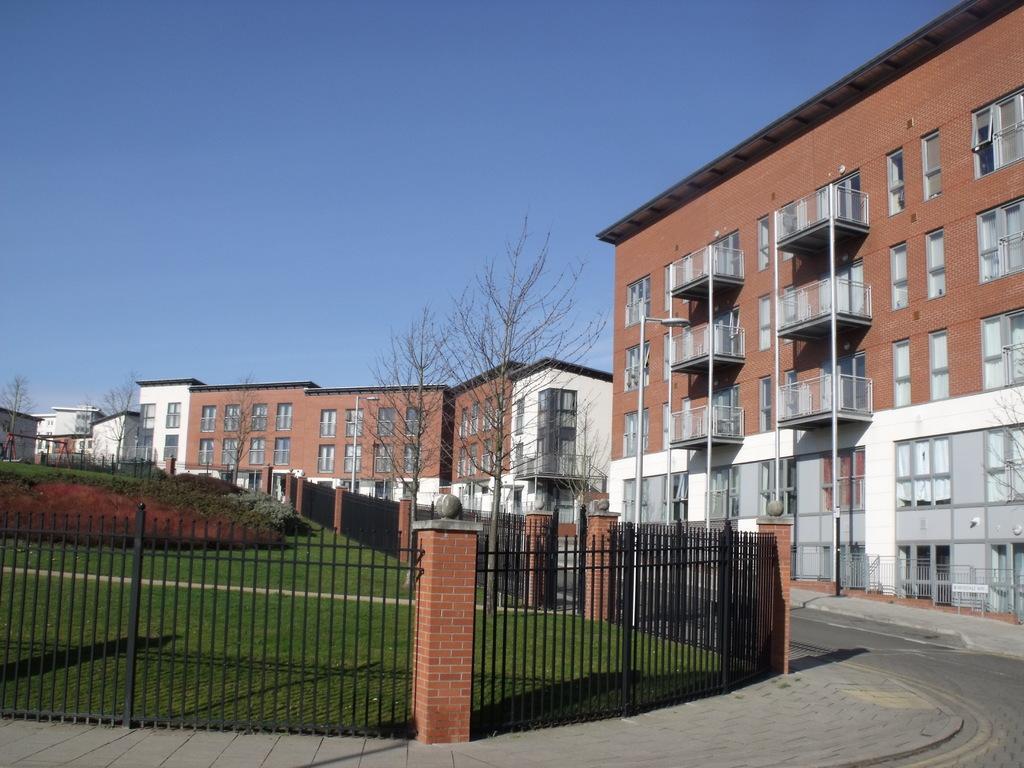Describe this image in one or two sentences. In this picture there are buildings in the center of the image and there is a boundary and grass land on the left side of the image. 